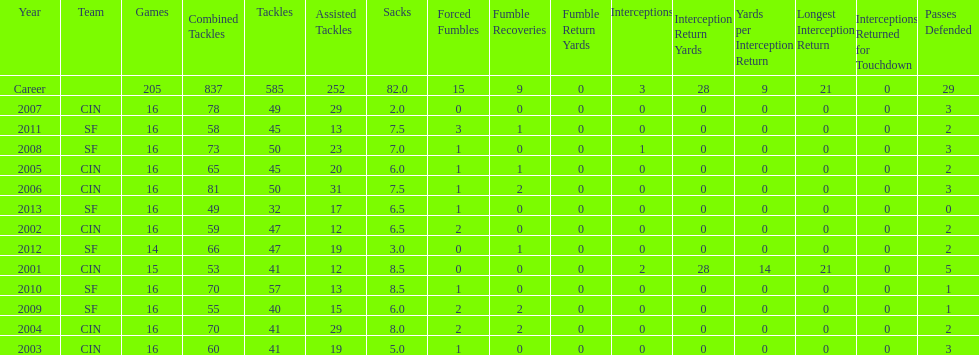What is the only season he has fewer than three sacks? 2007. 